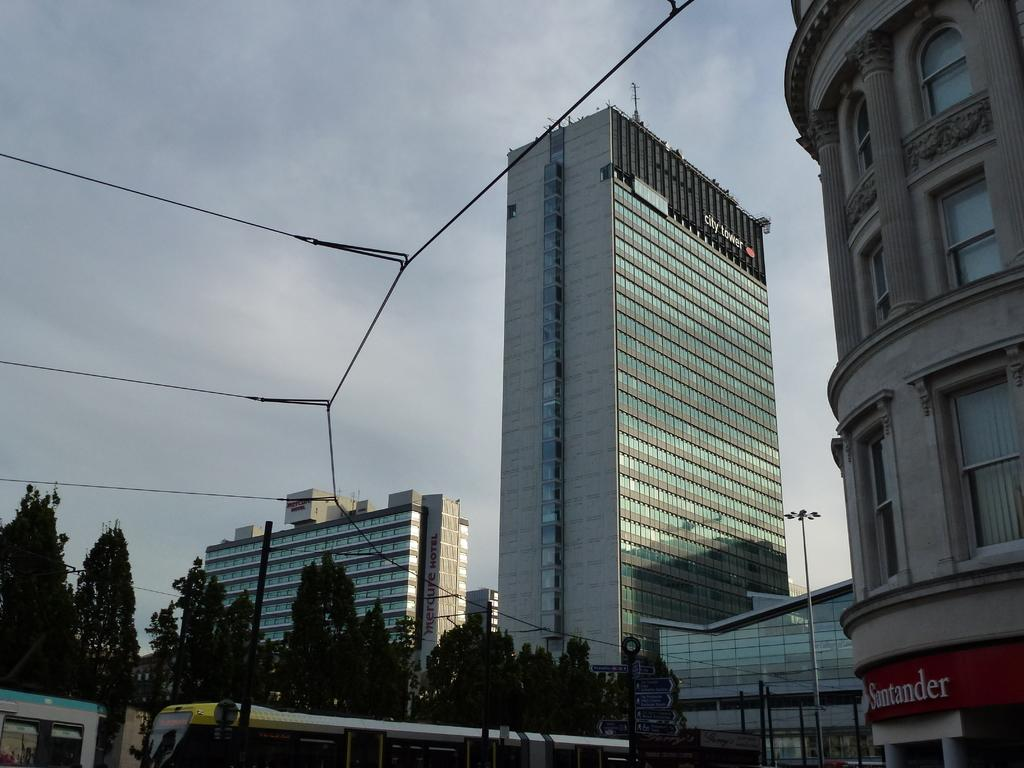What can be seen on the poles in the image? There are poles with directional boards and lights in the image. What is moving along the path in the image? There are vehicles on the path in the image. What type of vegetation is visible behind the poles? There are trees behind the poles in the image. What else is present behind the poles? Cables and buildings are present behind the poles in the image. What part of the natural environment is visible in the image? The sky is visible in the image. Can you tell me where the doctor is standing in the image? There is no doctor present in the image. What type of cover is provided by the trees in the image? The trees in the image do not provide any cover, as they are in the background and not directly over any objects or people. 